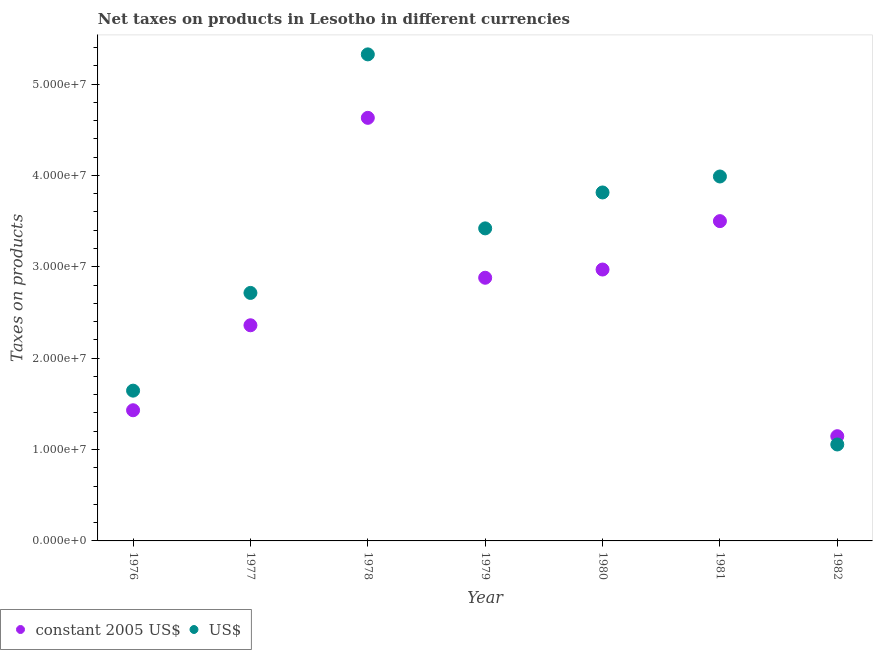How many different coloured dotlines are there?
Provide a short and direct response. 2. What is the net taxes in us$ in 1980?
Provide a short and direct response. 3.81e+07. Across all years, what is the maximum net taxes in us$?
Your answer should be compact. 5.32e+07. Across all years, what is the minimum net taxes in us$?
Provide a short and direct response. 1.06e+07. In which year was the net taxes in constant 2005 us$ maximum?
Offer a terse response. 1978. In which year was the net taxes in constant 2005 us$ minimum?
Keep it short and to the point. 1982. What is the total net taxes in constant 2005 us$ in the graph?
Offer a terse response. 1.89e+08. What is the difference between the net taxes in us$ in 1976 and that in 1979?
Provide a succinct answer. -1.78e+07. What is the difference between the net taxes in constant 2005 us$ in 1981 and the net taxes in us$ in 1979?
Your answer should be compact. 7.94e+05. What is the average net taxes in constant 2005 us$ per year?
Offer a terse response. 2.70e+07. In the year 1982, what is the difference between the net taxes in constant 2005 us$ and net taxes in us$?
Your answer should be very brief. 9.06e+05. What is the ratio of the net taxes in us$ in 1978 to that in 1979?
Make the answer very short. 1.56. Is the net taxes in us$ in 1977 less than that in 1981?
Provide a succinct answer. Yes. Is the difference between the net taxes in constant 2005 us$ in 1978 and 1982 greater than the difference between the net taxes in us$ in 1978 and 1982?
Your answer should be compact. No. What is the difference between the highest and the second highest net taxes in us$?
Your answer should be compact. 1.34e+07. What is the difference between the highest and the lowest net taxes in us$?
Your answer should be compact. 4.27e+07. In how many years, is the net taxes in us$ greater than the average net taxes in us$ taken over all years?
Offer a terse response. 4. Is the sum of the net taxes in us$ in 1978 and 1982 greater than the maximum net taxes in constant 2005 us$ across all years?
Offer a terse response. Yes. Is the net taxes in us$ strictly less than the net taxes in constant 2005 us$ over the years?
Provide a succinct answer. No. How many dotlines are there?
Offer a terse response. 2. How many years are there in the graph?
Keep it short and to the point. 7. What is the title of the graph?
Provide a succinct answer. Net taxes on products in Lesotho in different currencies. Does "Girls" appear as one of the legend labels in the graph?
Give a very brief answer. No. What is the label or title of the X-axis?
Offer a very short reply. Year. What is the label or title of the Y-axis?
Your answer should be compact. Taxes on products. What is the Taxes on products in constant 2005 US$ in 1976?
Your answer should be compact. 1.43e+07. What is the Taxes on products of US$ in 1976?
Offer a very short reply. 1.64e+07. What is the Taxes on products of constant 2005 US$ in 1977?
Ensure brevity in your answer.  2.36e+07. What is the Taxes on products of US$ in 1977?
Provide a short and direct response. 2.71e+07. What is the Taxes on products in constant 2005 US$ in 1978?
Make the answer very short. 4.63e+07. What is the Taxes on products of US$ in 1978?
Your answer should be very brief. 5.32e+07. What is the Taxes on products of constant 2005 US$ in 1979?
Offer a very short reply. 2.88e+07. What is the Taxes on products in US$ in 1979?
Your answer should be very brief. 3.42e+07. What is the Taxes on products in constant 2005 US$ in 1980?
Provide a short and direct response. 2.97e+07. What is the Taxes on products in US$ in 1980?
Your answer should be compact. 3.81e+07. What is the Taxes on products in constant 2005 US$ in 1981?
Make the answer very short. 3.50e+07. What is the Taxes on products of US$ in 1981?
Your answer should be compact. 3.99e+07. What is the Taxes on products of constant 2005 US$ in 1982?
Provide a succinct answer. 1.15e+07. What is the Taxes on products in US$ in 1982?
Your answer should be very brief. 1.06e+07. Across all years, what is the maximum Taxes on products in constant 2005 US$?
Give a very brief answer. 4.63e+07. Across all years, what is the maximum Taxes on products in US$?
Give a very brief answer. 5.32e+07. Across all years, what is the minimum Taxes on products of constant 2005 US$?
Your response must be concise. 1.15e+07. Across all years, what is the minimum Taxes on products in US$?
Offer a very short reply. 1.06e+07. What is the total Taxes on products of constant 2005 US$ in the graph?
Provide a succinct answer. 1.89e+08. What is the total Taxes on products in US$ in the graph?
Give a very brief answer. 2.20e+08. What is the difference between the Taxes on products in constant 2005 US$ in 1976 and that in 1977?
Offer a very short reply. -9.30e+06. What is the difference between the Taxes on products in US$ in 1976 and that in 1977?
Make the answer very short. -1.07e+07. What is the difference between the Taxes on products of constant 2005 US$ in 1976 and that in 1978?
Provide a succinct answer. -3.20e+07. What is the difference between the Taxes on products of US$ in 1976 and that in 1978?
Provide a short and direct response. -3.68e+07. What is the difference between the Taxes on products in constant 2005 US$ in 1976 and that in 1979?
Offer a terse response. -1.45e+07. What is the difference between the Taxes on products of US$ in 1976 and that in 1979?
Your answer should be compact. -1.78e+07. What is the difference between the Taxes on products in constant 2005 US$ in 1976 and that in 1980?
Offer a terse response. -1.54e+07. What is the difference between the Taxes on products of US$ in 1976 and that in 1980?
Give a very brief answer. -2.17e+07. What is the difference between the Taxes on products of constant 2005 US$ in 1976 and that in 1981?
Provide a short and direct response. -2.07e+07. What is the difference between the Taxes on products of US$ in 1976 and that in 1981?
Your answer should be very brief. -2.34e+07. What is the difference between the Taxes on products of constant 2005 US$ in 1976 and that in 1982?
Ensure brevity in your answer.  2.84e+06. What is the difference between the Taxes on products in US$ in 1976 and that in 1982?
Offer a terse response. 5.89e+06. What is the difference between the Taxes on products in constant 2005 US$ in 1977 and that in 1978?
Ensure brevity in your answer.  -2.27e+07. What is the difference between the Taxes on products in US$ in 1977 and that in 1978?
Keep it short and to the point. -2.61e+07. What is the difference between the Taxes on products of constant 2005 US$ in 1977 and that in 1979?
Keep it short and to the point. -5.20e+06. What is the difference between the Taxes on products of US$ in 1977 and that in 1979?
Give a very brief answer. -7.06e+06. What is the difference between the Taxes on products of constant 2005 US$ in 1977 and that in 1980?
Keep it short and to the point. -6.10e+06. What is the difference between the Taxes on products of US$ in 1977 and that in 1980?
Provide a short and direct response. -1.10e+07. What is the difference between the Taxes on products in constant 2005 US$ in 1977 and that in 1981?
Offer a very short reply. -1.14e+07. What is the difference between the Taxes on products in US$ in 1977 and that in 1981?
Offer a terse response. -1.27e+07. What is the difference between the Taxes on products of constant 2005 US$ in 1977 and that in 1982?
Keep it short and to the point. 1.21e+07. What is the difference between the Taxes on products in US$ in 1977 and that in 1982?
Ensure brevity in your answer.  1.66e+07. What is the difference between the Taxes on products of constant 2005 US$ in 1978 and that in 1979?
Provide a short and direct response. 1.75e+07. What is the difference between the Taxes on products of US$ in 1978 and that in 1979?
Make the answer very short. 1.90e+07. What is the difference between the Taxes on products in constant 2005 US$ in 1978 and that in 1980?
Provide a succinct answer. 1.66e+07. What is the difference between the Taxes on products of US$ in 1978 and that in 1980?
Keep it short and to the point. 1.51e+07. What is the difference between the Taxes on products of constant 2005 US$ in 1978 and that in 1981?
Your answer should be compact. 1.13e+07. What is the difference between the Taxes on products in US$ in 1978 and that in 1981?
Ensure brevity in your answer.  1.34e+07. What is the difference between the Taxes on products of constant 2005 US$ in 1978 and that in 1982?
Provide a succinct answer. 3.48e+07. What is the difference between the Taxes on products of US$ in 1978 and that in 1982?
Keep it short and to the point. 4.27e+07. What is the difference between the Taxes on products in constant 2005 US$ in 1979 and that in 1980?
Keep it short and to the point. -9.00e+05. What is the difference between the Taxes on products in US$ in 1979 and that in 1980?
Your answer should be very brief. -3.93e+06. What is the difference between the Taxes on products in constant 2005 US$ in 1979 and that in 1981?
Your response must be concise. -6.20e+06. What is the difference between the Taxes on products of US$ in 1979 and that in 1981?
Make the answer very short. -5.68e+06. What is the difference between the Taxes on products of constant 2005 US$ in 1979 and that in 1982?
Provide a short and direct response. 1.73e+07. What is the difference between the Taxes on products of US$ in 1979 and that in 1982?
Your answer should be very brief. 2.36e+07. What is the difference between the Taxes on products in constant 2005 US$ in 1980 and that in 1981?
Provide a short and direct response. -5.30e+06. What is the difference between the Taxes on products of US$ in 1980 and that in 1981?
Your response must be concise. -1.75e+06. What is the difference between the Taxes on products in constant 2005 US$ in 1980 and that in 1982?
Give a very brief answer. 1.82e+07. What is the difference between the Taxes on products in US$ in 1980 and that in 1982?
Your answer should be compact. 2.76e+07. What is the difference between the Taxes on products in constant 2005 US$ in 1981 and that in 1982?
Give a very brief answer. 2.35e+07. What is the difference between the Taxes on products of US$ in 1981 and that in 1982?
Make the answer very short. 2.93e+07. What is the difference between the Taxes on products of constant 2005 US$ in 1976 and the Taxes on products of US$ in 1977?
Your response must be concise. -1.28e+07. What is the difference between the Taxes on products in constant 2005 US$ in 1976 and the Taxes on products in US$ in 1978?
Your answer should be very brief. -3.89e+07. What is the difference between the Taxes on products of constant 2005 US$ in 1976 and the Taxes on products of US$ in 1979?
Offer a very short reply. -1.99e+07. What is the difference between the Taxes on products in constant 2005 US$ in 1976 and the Taxes on products in US$ in 1980?
Give a very brief answer. -2.38e+07. What is the difference between the Taxes on products in constant 2005 US$ in 1976 and the Taxes on products in US$ in 1981?
Provide a short and direct response. -2.56e+07. What is the difference between the Taxes on products of constant 2005 US$ in 1976 and the Taxes on products of US$ in 1982?
Your response must be concise. 3.74e+06. What is the difference between the Taxes on products of constant 2005 US$ in 1977 and the Taxes on products of US$ in 1978?
Give a very brief answer. -2.96e+07. What is the difference between the Taxes on products in constant 2005 US$ in 1977 and the Taxes on products in US$ in 1979?
Provide a succinct answer. -1.06e+07. What is the difference between the Taxes on products of constant 2005 US$ in 1977 and the Taxes on products of US$ in 1980?
Provide a succinct answer. -1.45e+07. What is the difference between the Taxes on products of constant 2005 US$ in 1977 and the Taxes on products of US$ in 1981?
Your response must be concise. -1.63e+07. What is the difference between the Taxes on products of constant 2005 US$ in 1977 and the Taxes on products of US$ in 1982?
Your response must be concise. 1.30e+07. What is the difference between the Taxes on products in constant 2005 US$ in 1978 and the Taxes on products in US$ in 1979?
Provide a short and direct response. 1.21e+07. What is the difference between the Taxes on products in constant 2005 US$ in 1978 and the Taxes on products in US$ in 1980?
Your answer should be very brief. 8.17e+06. What is the difference between the Taxes on products of constant 2005 US$ in 1978 and the Taxes on products of US$ in 1981?
Your answer should be very brief. 6.42e+06. What is the difference between the Taxes on products in constant 2005 US$ in 1978 and the Taxes on products in US$ in 1982?
Offer a terse response. 3.57e+07. What is the difference between the Taxes on products in constant 2005 US$ in 1979 and the Taxes on products in US$ in 1980?
Your answer should be very brief. -9.33e+06. What is the difference between the Taxes on products of constant 2005 US$ in 1979 and the Taxes on products of US$ in 1981?
Ensure brevity in your answer.  -1.11e+07. What is the difference between the Taxes on products of constant 2005 US$ in 1979 and the Taxes on products of US$ in 1982?
Offer a terse response. 1.82e+07. What is the difference between the Taxes on products of constant 2005 US$ in 1980 and the Taxes on products of US$ in 1981?
Give a very brief answer. -1.02e+07. What is the difference between the Taxes on products in constant 2005 US$ in 1980 and the Taxes on products in US$ in 1982?
Keep it short and to the point. 1.91e+07. What is the difference between the Taxes on products of constant 2005 US$ in 1981 and the Taxes on products of US$ in 1982?
Give a very brief answer. 2.44e+07. What is the average Taxes on products in constant 2005 US$ per year?
Your response must be concise. 2.70e+07. What is the average Taxes on products in US$ per year?
Provide a succinct answer. 3.14e+07. In the year 1976, what is the difference between the Taxes on products of constant 2005 US$ and Taxes on products of US$?
Your response must be concise. -2.14e+06. In the year 1977, what is the difference between the Taxes on products in constant 2005 US$ and Taxes on products in US$?
Your answer should be very brief. -3.54e+06. In the year 1978, what is the difference between the Taxes on products in constant 2005 US$ and Taxes on products in US$?
Your answer should be compact. -6.94e+06. In the year 1979, what is the difference between the Taxes on products of constant 2005 US$ and Taxes on products of US$?
Offer a very short reply. -5.40e+06. In the year 1980, what is the difference between the Taxes on products in constant 2005 US$ and Taxes on products in US$?
Make the answer very short. -8.43e+06. In the year 1981, what is the difference between the Taxes on products of constant 2005 US$ and Taxes on products of US$?
Make the answer very short. -4.88e+06. In the year 1982, what is the difference between the Taxes on products of constant 2005 US$ and Taxes on products of US$?
Keep it short and to the point. 9.06e+05. What is the ratio of the Taxes on products of constant 2005 US$ in 1976 to that in 1977?
Give a very brief answer. 0.61. What is the ratio of the Taxes on products in US$ in 1976 to that in 1977?
Your answer should be compact. 0.61. What is the ratio of the Taxes on products of constant 2005 US$ in 1976 to that in 1978?
Provide a short and direct response. 0.31. What is the ratio of the Taxes on products of US$ in 1976 to that in 1978?
Offer a terse response. 0.31. What is the ratio of the Taxes on products in constant 2005 US$ in 1976 to that in 1979?
Your answer should be compact. 0.5. What is the ratio of the Taxes on products in US$ in 1976 to that in 1979?
Offer a very short reply. 0.48. What is the ratio of the Taxes on products of constant 2005 US$ in 1976 to that in 1980?
Ensure brevity in your answer.  0.48. What is the ratio of the Taxes on products of US$ in 1976 to that in 1980?
Offer a very short reply. 0.43. What is the ratio of the Taxes on products in constant 2005 US$ in 1976 to that in 1981?
Your answer should be very brief. 0.41. What is the ratio of the Taxes on products of US$ in 1976 to that in 1981?
Your answer should be compact. 0.41. What is the ratio of the Taxes on products of constant 2005 US$ in 1976 to that in 1982?
Offer a terse response. 1.25. What is the ratio of the Taxes on products in US$ in 1976 to that in 1982?
Provide a short and direct response. 1.56. What is the ratio of the Taxes on products in constant 2005 US$ in 1977 to that in 1978?
Your answer should be very brief. 0.51. What is the ratio of the Taxes on products of US$ in 1977 to that in 1978?
Give a very brief answer. 0.51. What is the ratio of the Taxes on products of constant 2005 US$ in 1977 to that in 1979?
Offer a very short reply. 0.82. What is the ratio of the Taxes on products in US$ in 1977 to that in 1979?
Provide a short and direct response. 0.79. What is the ratio of the Taxes on products of constant 2005 US$ in 1977 to that in 1980?
Your answer should be very brief. 0.79. What is the ratio of the Taxes on products in US$ in 1977 to that in 1980?
Offer a terse response. 0.71. What is the ratio of the Taxes on products in constant 2005 US$ in 1977 to that in 1981?
Provide a succinct answer. 0.67. What is the ratio of the Taxes on products of US$ in 1977 to that in 1981?
Offer a very short reply. 0.68. What is the ratio of the Taxes on products of constant 2005 US$ in 1977 to that in 1982?
Provide a succinct answer. 2.06. What is the ratio of the Taxes on products in US$ in 1977 to that in 1982?
Make the answer very short. 2.57. What is the ratio of the Taxes on products in constant 2005 US$ in 1978 to that in 1979?
Your answer should be compact. 1.61. What is the ratio of the Taxes on products of US$ in 1978 to that in 1979?
Provide a short and direct response. 1.56. What is the ratio of the Taxes on products of constant 2005 US$ in 1978 to that in 1980?
Make the answer very short. 1.56. What is the ratio of the Taxes on products in US$ in 1978 to that in 1980?
Ensure brevity in your answer.  1.4. What is the ratio of the Taxes on products of constant 2005 US$ in 1978 to that in 1981?
Offer a terse response. 1.32. What is the ratio of the Taxes on products in US$ in 1978 to that in 1981?
Give a very brief answer. 1.34. What is the ratio of the Taxes on products in constant 2005 US$ in 1978 to that in 1982?
Ensure brevity in your answer.  4.04. What is the ratio of the Taxes on products of US$ in 1978 to that in 1982?
Offer a very short reply. 5.04. What is the ratio of the Taxes on products of constant 2005 US$ in 1979 to that in 1980?
Provide a short and direct response. 0.97. What is the ratio of the Taxes on products in US$ in 1979 to that in 1980?
Offer a very short reply. 0.9. What is the ratio of the Taxes on products in constant 2005 US$ in 1979 to that in 1981?
Make the answer very short. 0.82. What is the ratio of the Taxes on products of US$ in 1979 to that in 1981?
Ensure brevity in your answer.  0.86. What is the ratio of the Taxes on products in constant 2005 US$ in 1979 to that in 1982?
Offer a terse response. 2.51. What is the ratio of the Taxes on products of US$ in 1979 to that in 1982?
Give a very brief answer. 3.24. What is the ratio of the Taxes on products in constant 2005 US$ in 1980 to that in 1981?
Offer a very short reply. 0.85. What is the ratio of the Taxes on products of US$ in 1980 to that in 1981?
Your answer should be compact. 0.96. What is the ratio of the Taxes on products in constant 2005 US$ in 1980 to that in 1982?
Your response must be concise. 2.59. What is the ratio of the Taxes on products of US$ in 1980 to that in 1982?
Your answer should be compact. 3.61. What is the ratio of the Taxes on products in constant 2005 US$ in 1981 to that in 1982?
Give a very brief answer. 3.05. What is the ratio of the Taxes on products in US$ in 1981 to that in 1982?
Your answer should be very brief. 3.78. What is the difference between the highest and the second highest Taxes on products in constant 2005 US$?
Offer a terse response. 1.13e+07. What is the difference between the highest and the second highest Taxes on products of US$?
Make the answer very short. 1.34e+07. What is the difference between the highest and the lowest Taxes on products of constant 2005 US$?
Provide a short and direct response. 3.48e+07. What is the difference between the highest and the lowest Taxes on products in US$?
Ensure brevity in your answer.  4.27e+07. 